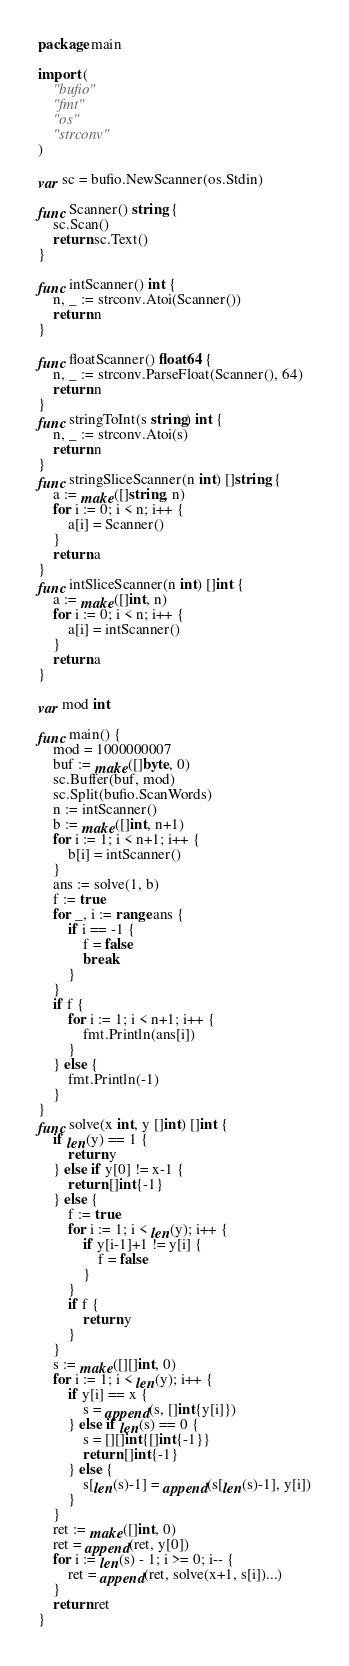Convert code to text. <code><loc_0><loc_0><loc_500><loc_500><_Go_>package main

import (
	"bufio"
	"fmt"
	"os"
	"strconv"
)

var sc = bufio.NewScanner(os.Stdin)

func Scanner() string {
	sc.Scan()
	return sc.Text()
}

func intScanner() int {
	n, _ := strconv.Atoi(Scanner())
	return n
}

func floatScanner() float64 {
	n, _ := strconv.ParseFloat(Scanner(), 64)
	return n
}
func stringToInt(s string) int {
	n, _ := strconv.Atoi(s)
	return n
}
func stringSliceScanner(n int) []string {
	a := make([]string, n)
	for i := 0; i < n; i++ {
		a[i] = Scanner()
	}
	return a
}
func intSliceScanner(n int) []int {
	a := make([]int, n)
	for i := 0; i < n; i++ {
		a[i] = intScanner()
	}
	return a
}

var mod int

func main() {
	mod = 1000000007
	buf := make([]byte, 0)
	sc.Buffer(buf, mod)
	sc.Split(bufio.ScanWords)
	n := intScanner()
	b := make([]int, n+1)
	for i := 1; i < n+1; i++ {
		b[i] = intScanner()
	}
	ans := solve(1, b)
	f := true
	for _, i := range ans {
		if i == -1 {
			f = false
			break
		}
	}
	if f {
		for i := 1; i < n+1; i++ {
			fmt.Println(ans[i])
		}
	} else {
		fmt.Println(-1)
	}
}
func solve(x int, y []int) []int {
	if len(y) == 1 {
		return y
	} else if y[0] != x-1 {
		return []int{-1}
	} else {
		f := true
		for i := 1; i < len(y); i++ {
			if y[i-1]+1 != y[i] {
				f = false
			}
		}
		if f {
			return y
		}
	}
	s := make([][]int, 0)
	for i := 1; i < len(y); i++ {
		if y[i] == x {
			s = append(s, []int{y[i]})
		} else if len(s) == 0 {
			s = [][]int{[]int{-1}}
			return []int{-1}
		} else {
			s[len(s)-1] = append(s[len(s)-1], y[i])
		}
	}
	ret := make([]int, 0)
	ret = append(ret, y[0])
	for i := len(s) - 1; i >= 0; i-- {
		ret = append(ret, solve(x+1, s[i])...)
	}
	return ret
}
</code> 